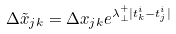Convert formula to latex. <formula><loc_0><loc_0><loc_500><loc_500>\Delta \tilde { x } _ { j k } = \Delta { x } _ { j k } e ^ { \lambda _ { \perp } ^ { + } | t _ { k } ^ { i } - t _ { j } ^ { i } | }</formula> 